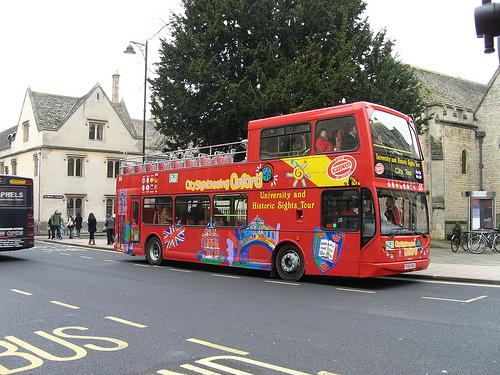Question: what vehicle is shown?
Choices:
A. Public bus.
B. City bus.
C. Tour bus.
D. Subway.
Answer with the letter. Answer: C Question: what color are the lines on the road?
Choices:
A. White.
B. Yellow.
C. Orange.
D. Red.
Answer with the letter. Answer: B Question: who is on the sidewalk?
Choices:
A. Workers.
B. People waiting on bus.
C. Traffic directors.
D. Pedestrians.
Answer with the letter. Answer: D Question: how many buses are shown?
Choices:
A. Two.
B. Three.
C. One.
D. None.
Answer with the letter. Answer: A 